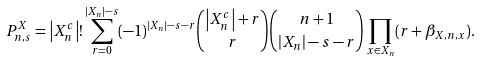Convert formula to latex. <formula><loc_0><loc_0><loc_500><loc_500>P _ { n , s } ^ { X } = \left | X _ { n } ^ { c } \right | ! \sum _ { r = 0 } ^ { \left | X _ { n } \right | - s } ( - 1 ) ^ { \left | X _ { n } \right | - s - r } \binom { \left | X _ { n } ^ { c } \right | + r } { r } \binom { n + 1 } { \left | X _ { n } \right | - s - r } \prod _ { x \in X _ { n } } ( r + \beta _ { X , n , x } ) .</formula> 